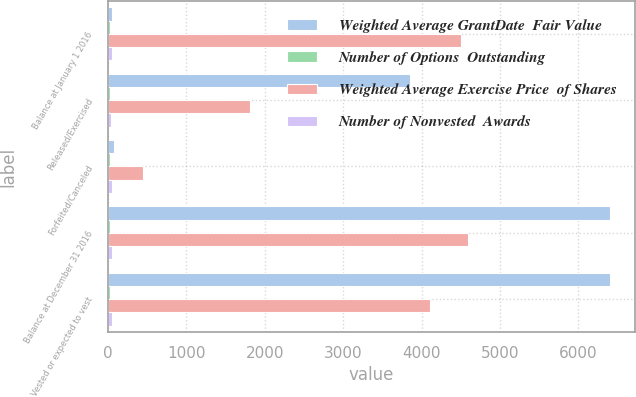Convert chart to OTSL. <chart><loc_0><loc_0><loc_500><loc_500><stacked_bar_chart><ecel><fcel>Balance at January 1 2016<fcel>Released/Exercised<fcel>Forfeited/Canceled<fcel>Balance at December 31 2016<fcel>Vested or expected to vest<nl><fcel>Weighted Average GrantDate  Fair Value<fcel>56.9<fcel>3851<fcel>73<fcel>6403<fcel>6403<nl><fcel>Number of Options  Outstanding<fcel>21.62<fcel>22.6<fcel>22.65<fcel>21.02<fcel>21.02<nl><fcel>Weighted Average Exercise Price  of Shares<fcel>4499<fcel>1810<fcel>446<fcel>4591<fcel>4112<nl><fcel>Number of Nonvested  Awards<fcel>50.02<fcel>45<fcel>55.06<fcel>56.9<fcel>56.64<nl></chart> 